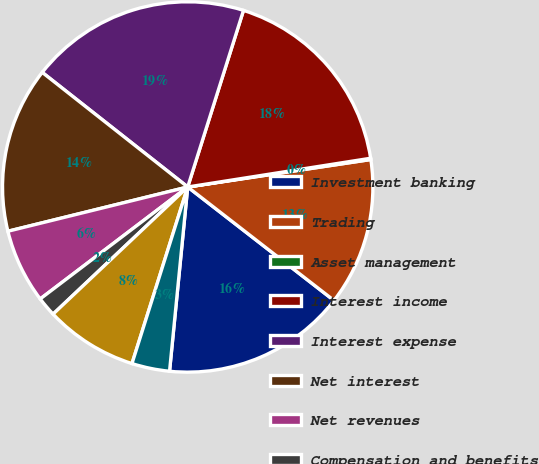Convert chart to OTSL. <chart><loc_0><loc_0><loc_500><loc_500><pie_chart><fcel>Investment banking<fcel>Trading<fcel>Asset management<fcel>Interest income<fcel>Interest expense<fcel>Net interest<fcel>Net revenues<fcel>Compensation and benefits<fcel>Non-compensation expenses<fcel>Total non-interest expenses<nl><fcel>16.06%<fcel>12.87%<fcel>0.11%<fcel>17.65%<fcel>19.25%<fcel>14.46%<fcel>6.49%<fcel>1.71%<fcel>8.09%<fcel>3.3%<nl></chart> 